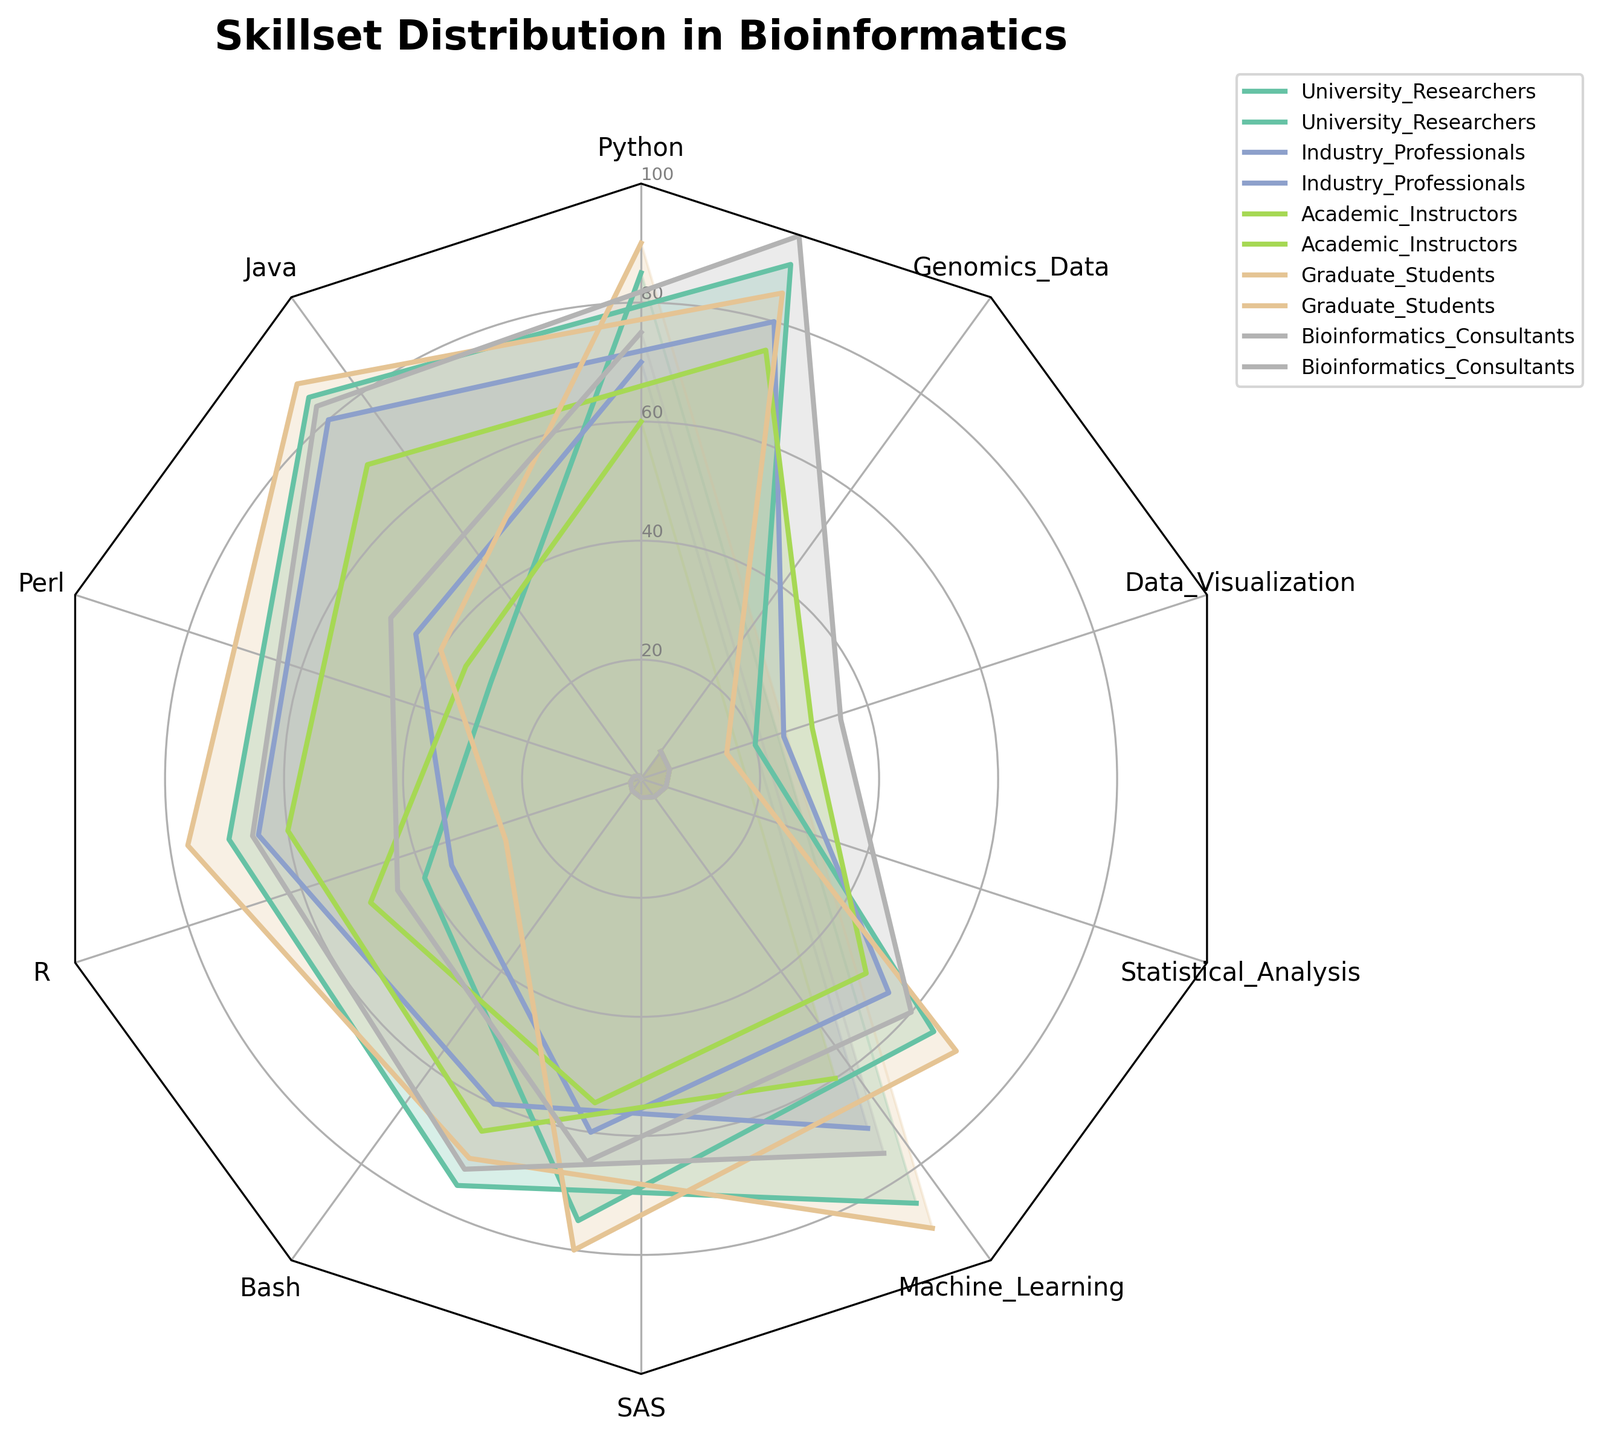What title is displayed at the top of the radar chart? The title is displayed prominently at the top of the radar chart.
Answer: Skillset Distribution in Bioinformatics Which group has the highest proficiency in Python? From the radar chart, identify the group with the largest section in the Python category.
Answer: Graduate Students What is the average skill level in Genomics Data across all groups? Add the values for Genomics Data from all groups: (75 + 60 + 65 + 70 + 72). Then divide by the number of groups (5).
Answer: 68.4 Which category has the lowest recorded proficiency by any group and what is the value? Identify the smallest section for any category within the radar chart.
Answer: SAS, 15 (Graduate Students) How do Industry Professionals' skills in Machine Learning compare to Statistical Analysis? Locate the Machine Learning and Statistical Analysis values for Industry Professionals and compare them.
Answer: Machine Learning: 80, Statistical Analysis: 80 What is the combined total proficiency in Bash for Academic Instructors and Bioinformatics Consultants? Add the Bash values for Academic Instructors and Bioinformatics Consultants: (50 + 60).
Answer: 110 Which group's skills in R are closest to their skills in Perl? Identify the group with the smallest difference between R and Perl values.
Answer: University Researchers (R: 75, Perl: 40) Rank the groups based on their proficiency in Data Visualization from highest to lowest. Order the groups by their values in Data Visualization.
Answer: Graduate Students (77), University Researchers (70), Bioinformatics Consultants (66), Academic Instructors (60), Industry Professionals (65) What is the difference in Statistical Analysis proficiency between the group with the highest and the group with the lowest proficiency? Find the highest and lowest values for Statistical Analysis and calculate the difference.
Answer: Highest: 88 (Graduate Students), Lowest: 70 (Academic Instructors), Difference: 18 From the chart, which group demonstrates the most balanced skillset across all categories? Identify the group whose values are most consistent across categories, indicated by a more evenly shaped polygon.
Answer: Bioinformatics Consultants 